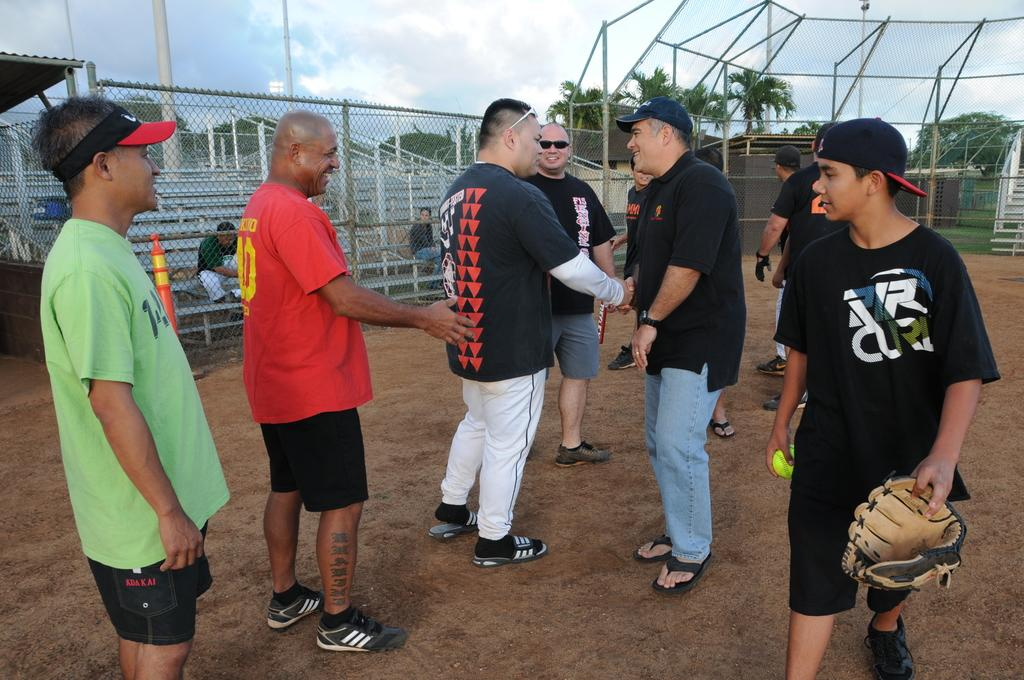<image>
Create a compact narrative representing the image presented. A group of guys on a baseball field and one wears a VR shirt 